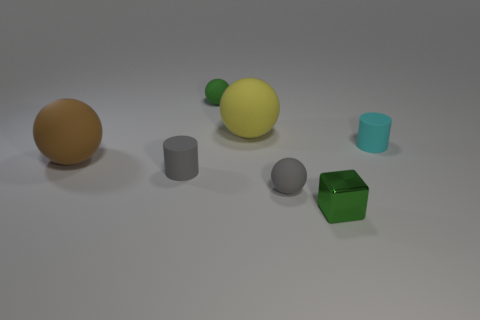Subtract 1 spheres. How many spheres are left? 3 Add 2 small blocks. How many objects exist? 9 Subtract all cylinders. How many objects are left? 5 Add 7 small cyan objects. How many small cyan objects are left? 8 Add 4 small cylinders. How many small cylinders exist? 6 Subtract 1 green spheres. How many objects are left? 6 Subtract all big matte cylinders. Subtract all small matte things. How many objects are left? 3 